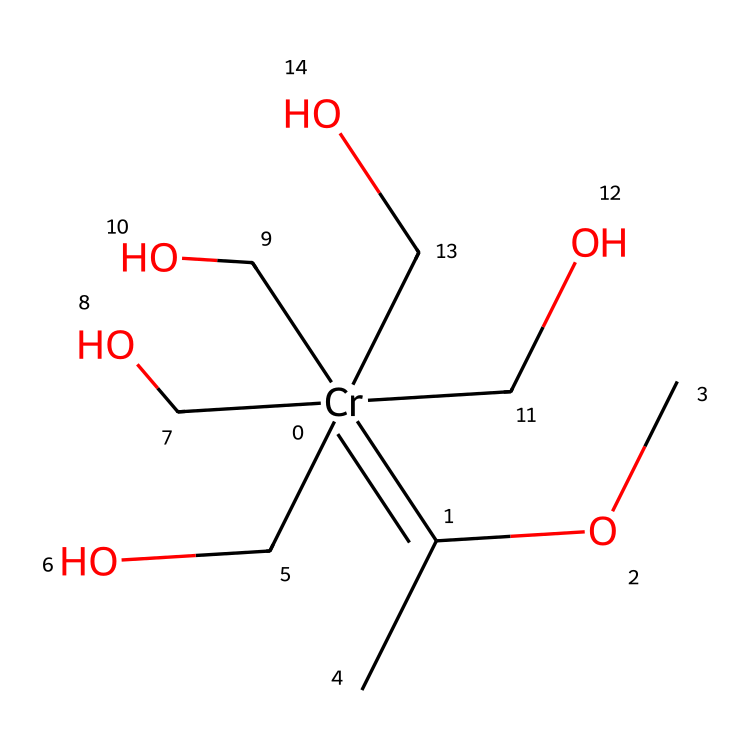What is the central metal in this complex? The structure contains a chromium atom (Cr) as indicated by its presence in the SMILES representation.
Answer: chromium How many alkoxy groups are present in the structure? The SMILES representation indicates five -OCH3 (methoxy) groups, each represented by “OC” in succession.
Answer: five What type of carbene is represented here? This structure is a Fischer carbene because it has a metal center bonded to a carbon atom with a substituent, consistent with Fischer's classification.
Answer: Fischer What is the total number of carbon atoms in the chemical? Counting the carbon atoms in the SMILES representation, we have one from the carbene site and five from the alkoxy groups plus one central carbon, totaling seven carbon atoms.
Answer: seven What type of coordination does the chromium exhibit here? The chromium is bonded to multiple substituents, indicative of a coordination complex structure with multiple ligands, specifically monodentate alkoxy ligands.
Answer: coordination complex What functional groups are found in this compound? The main functional group present is the ether (from -OCH3), and the carbene functionality is represented by the -C=C- structure.
Answer: ether, carbene 